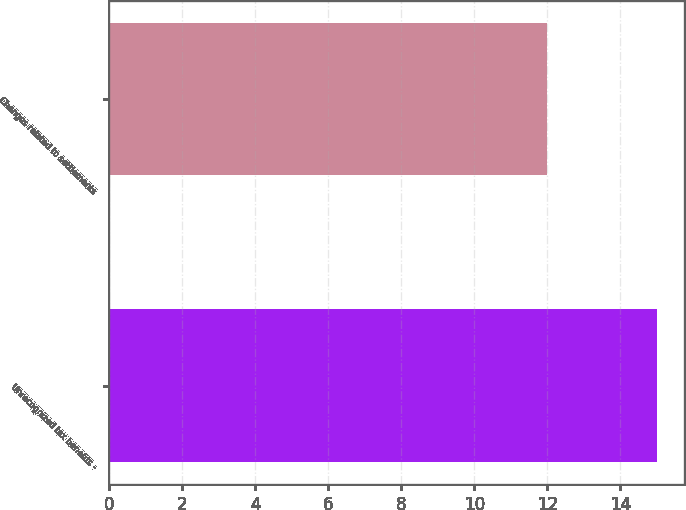Convert chart. <chart><loc_0><loc_0><loc_500><loc_500><bar_chart><fcel>Unrecognized tax benefits -<fcel>Changes related to settlements<nl><fcel>15<fcel>12<nl></chart> 